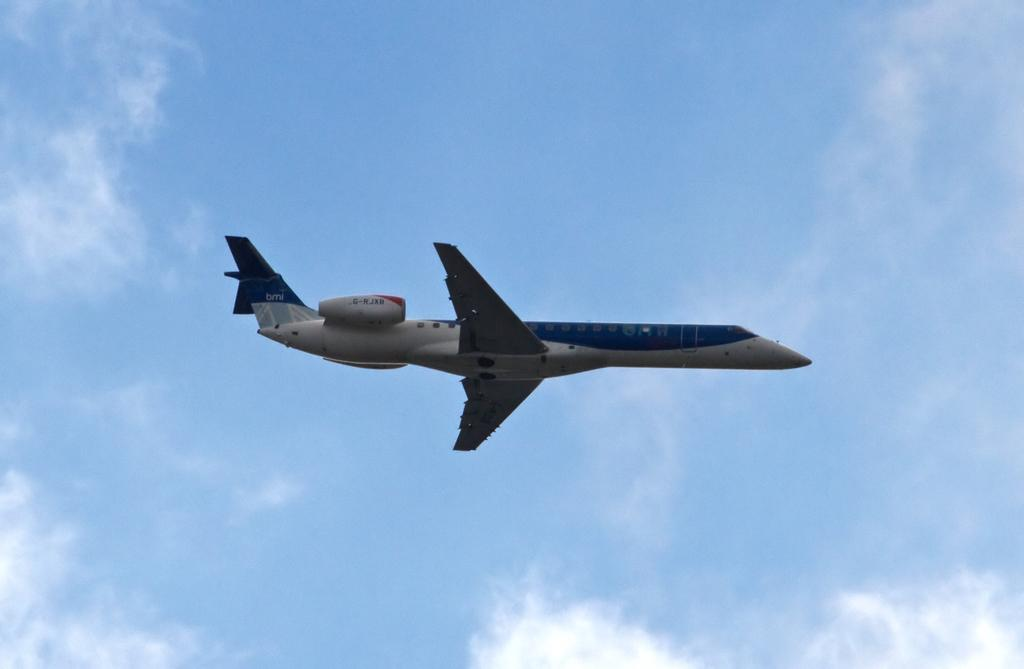What is the main subject of the image? The main subject of the image is an airplane. What is the airplane doing in the image? The airplane is flying in the sky. What type of drain is visible on the back of the airplane in the image? There is no drain visible on the airplane in the image, as it is flying in the sky. 